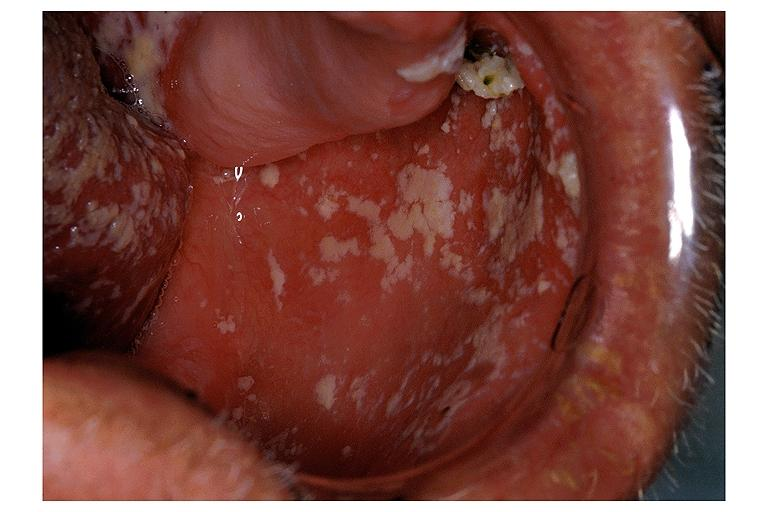does other x-rays show candidiasis-pseudomembraneous?
Answer the question using a single word or phrase. No 